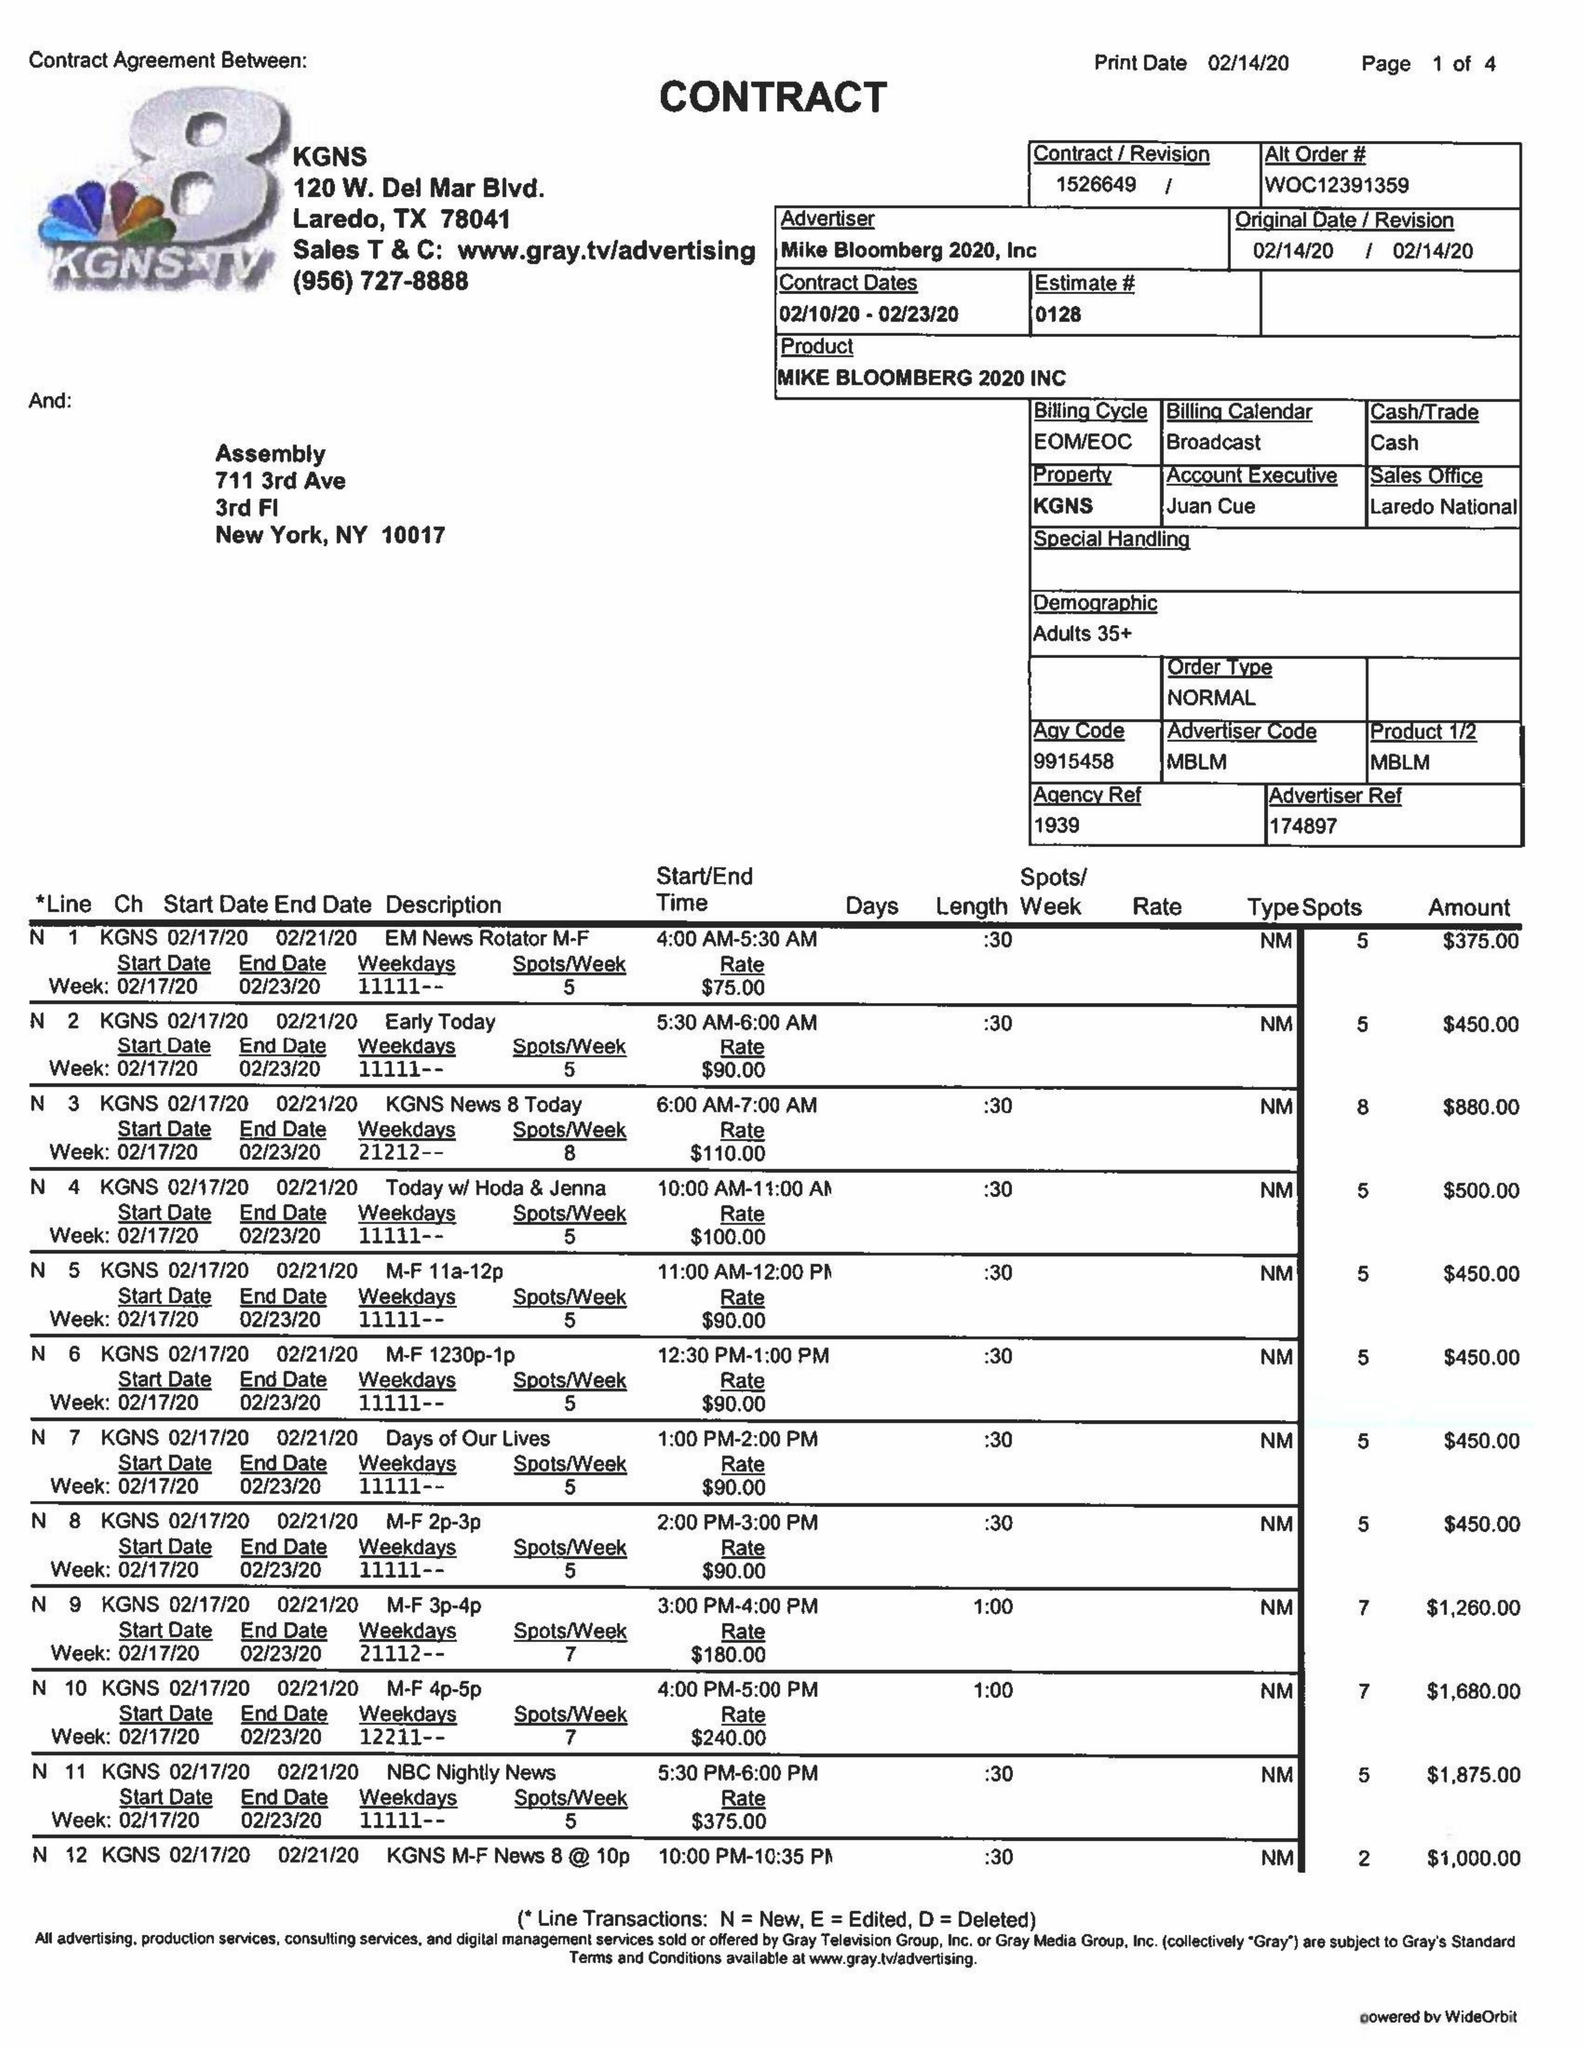What is the value for the contract_num?
Answer the question using a single word or phrase. 1526649 